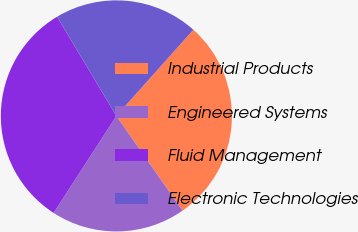<chart> <loc_0><loc_0><loc_500><loc_500><pie_chart><fcel>Industrial Products<fcel>Engineered Systems<fcel>Fluid Management<fcel>Electronic Technologies<nl><fcel>28.7%<fcel>18.83%<fcel>32.29%<fcel>20.18%<nl></chart> 